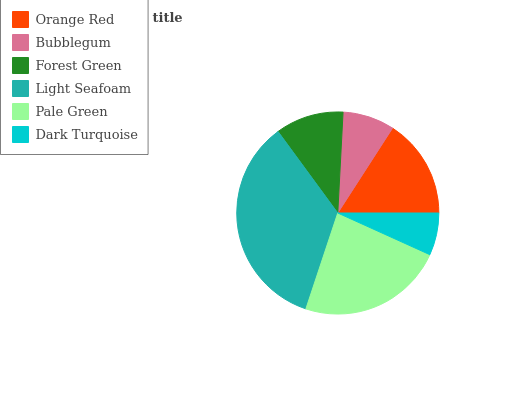Is Dark Turquoise the minimum?
Answer yes or no. Yes. Is Light Seafoam the maximum?
Answer yes or no. Yes. Is Bubblegum the minimum?
Answer yes or no. No. Is Bubblegum the maximum?
Answer yes or no. No. Is Orange Red greater than Bubblegum?
Answer yes or no. Yes. Is Bubblegum less than Orange Red?
Answer yes or no. Yes. Is Bubblegum greater than Orange Red?
Answer yes or no. No. Is Orange Red less than Bubblegum?
Answer yes or no. No. Is Orange Red the high median?
Answer yes or no. Yes. Is Forest Green the low median?
Answer yes or no. Yes. Is Bubblegum the high median?
Answer yes or no. No. Is Dark Turquoise the low median?
Answer yes or no. No. 